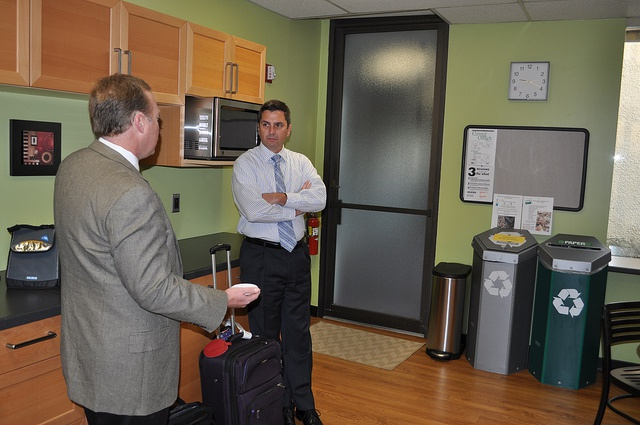Describe the objects in this image and their specific colors. I can see people in brown and gray tones, people in brown, black, and darkgray tones, suitcase in brown, black, and maroon tones, chair in brown, black, gray, and maroon tones, and microwave in brown, black, gray, darkgray, and lavender tones in this image. 